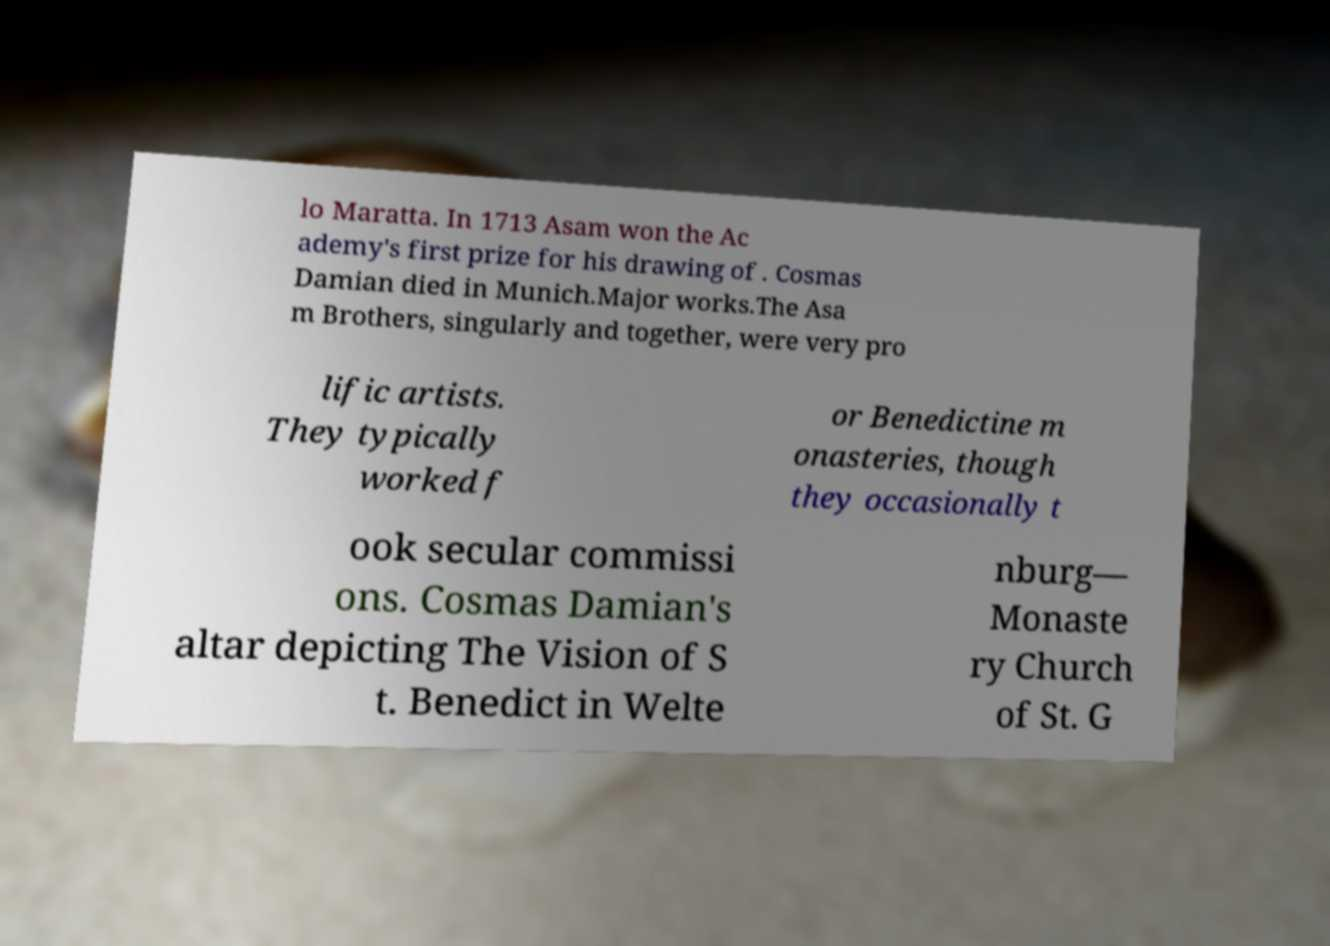I need the written content from this picture converted into text. Can you do that? lo Maratta. In 1713 Asam won the Ac ademy's first prize for his drawing of . Cosmas Damian died in Munich.Major works.The Asa m Brothers, singularly and together, were very pro lific artists. They typically worked f or Benedictine m onasteries, though they occasionally t ook secular commissi ons. Cosmas Damian's altar depicting The Vision of S t. Benedict in Welte nburg— Monaste ry Church of St. G 